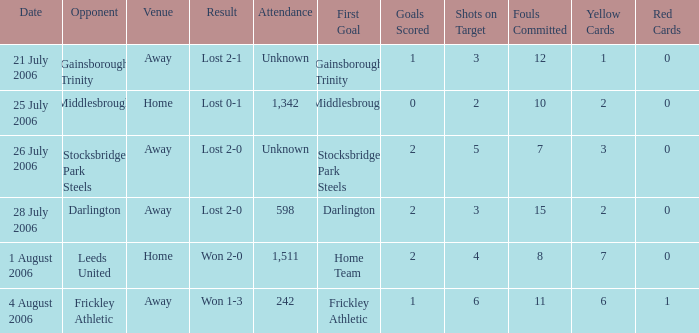What is the attendance rate for the Middlesbrough opponent? 1342.0. 